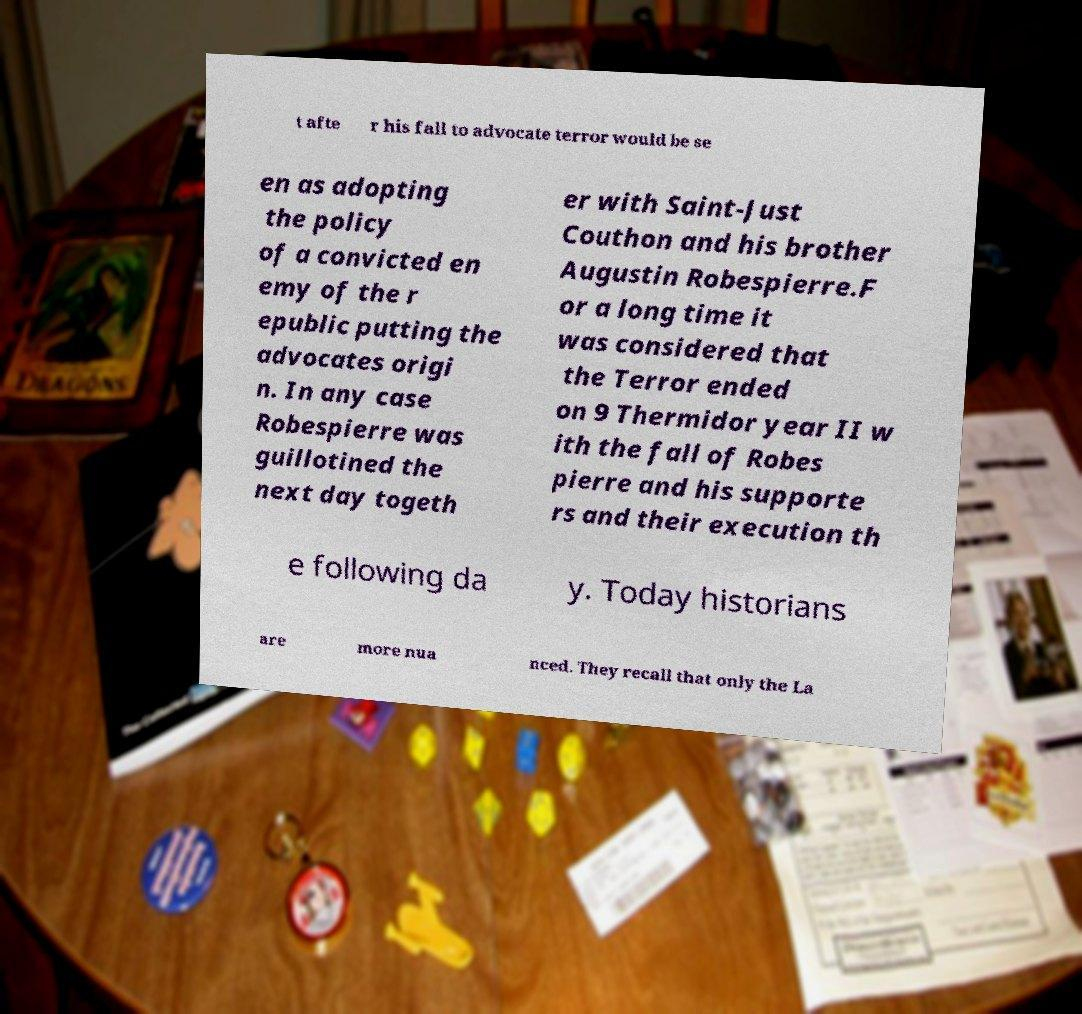Please read and relay the text visible in this image. What does it say? t afte r his fall to advocate terror would be se en as adopting the policy of a convicted en emy of the r epublic putting the advocates origi n. In any case Robespierre was guillotined the next day togeth er with Saint-Just Couthon and his brother Augustin Robespierre.F or a long time it was considered that the Terror ended on 9 Thermidor year II w ith the fall of Robes pierre and his supporte rs and their execution th e following da y. Today historians are more nua nced. They recall that only the La 